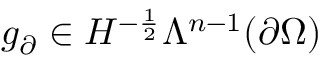<formula> <loc_0><loc_0><loc_500><loc_500>g _ { \partial } \in H ^ { - \frac { 1 } { 2 } } \Lambda ^ { n - 1 } ( \partial \Omega )</formula> 